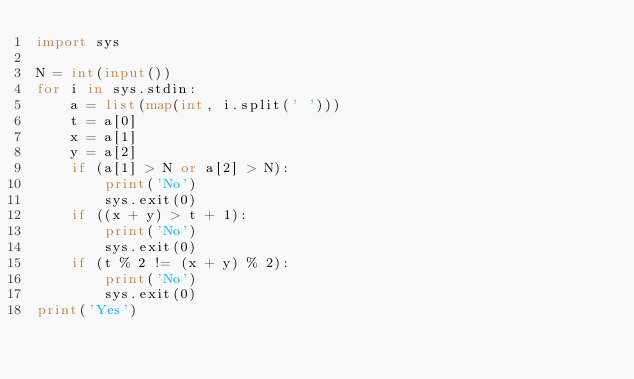<code> <loc_0><loc_0><loc_500><loc_500><_Python_>import sys

N = int(input())
for i in sys.stdin:
    a = list(map(int, i.split(' ')))
    t = a[0]
    x = a[1]
    y = a[2]
    if (a[1] > N or a[2] > N):
        print('No')
        sys.exit(0)
    if ((x + y) > t + 1):
        print('No')
        sys.exit(0)
    if (t % 2 != (x + y) % 2):
        print('No')
        sys.exit(0)
print('Yes')</code> 